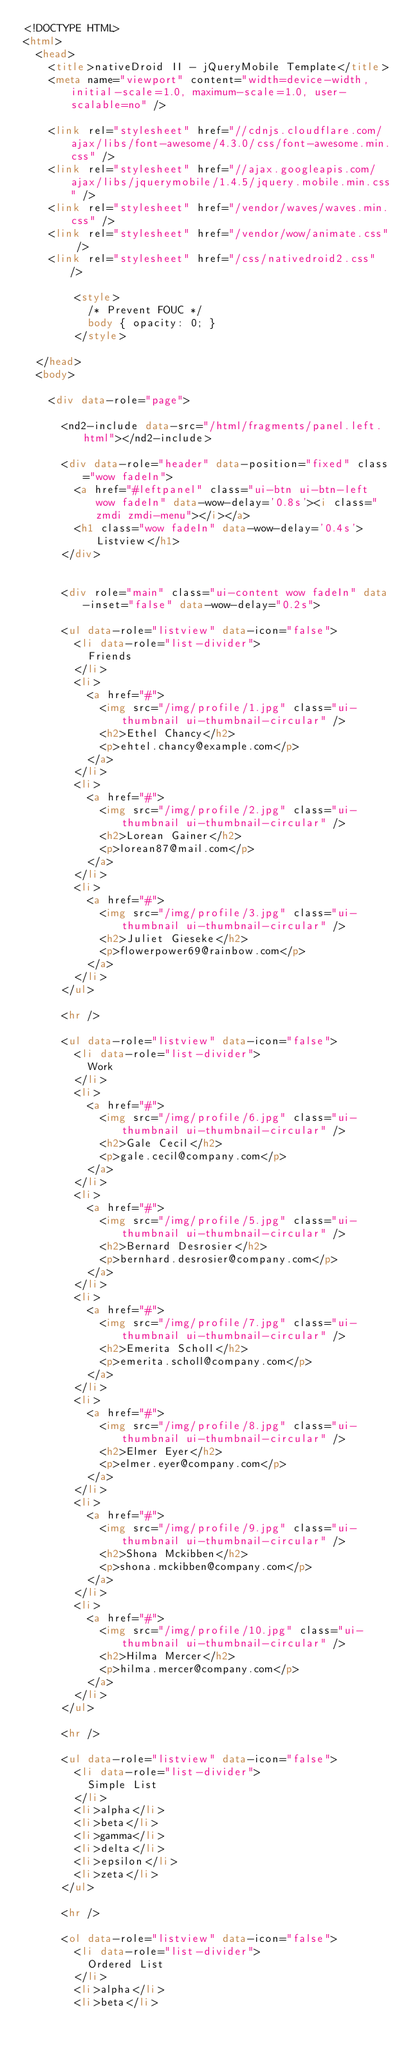<code> <loc_0><loc_0><loc_500><loc_500><_HTML_><!DOCTYPE HTML>
<html>
	<head>
		<title>nativeDroid II - jQueryMobile Template</title>
		<meta name="viewport" content="width=device-width, initial-scale=1.0, maximum-scale=1.0, user-scalable=no" />

		<link rel="stylesheet" href="//cdnjs.cloudflare.com/ajax/libs/font-awesome/4.3.0/css/font-awesome.min.css" />
		<link rel="stylesheet" href="//ajax.googleapis.com/ajax/libs/jquerymobile/1.4.5/jquery.mobile.min.css" />
		<link rel="stylesheet" href="/vendor/waves/waves.min.css" />
		<link rel="stylesheet" href="/vendor/wow/animate.css" />
		<link rel="stylesheet" href="/css/nativedroid2.css" />

				<style>
					/* Prevent FOUC */
					body { opacity: 0; }
				</style>

	</head>
	<body>

		<div data-role="page">

			<nd2-include data-src="/html/fragments/panel.left.html"></nd2-include>

			<div data-role="header" data-position="fixed" class="wow fadeIn">
				<a href="#leftpanel" class="ui-btn ui-btn-left wow fadeIn" data-wow-delay='0.8s'><i class="zmdi zmdi-menu"></i></a>
				<h1 class="wow fadeIn" data-wow-delay='0.4s'>Listview</h1>
			</div>


			<div role="main" class="ui-content wow fadeIn" data-inset="false" data-wow-delay="0.2s">

			<ul data-role="listview" data-icon="false">
				<li data-role="list-divider">
					Friends
				</li>
				<li>
					<a href="#">
						<img src="/img/profile/1.jpg" class="ui-thumbnail ui-thumbnail-circular" />
						<h2>Ethel Chancy</h2>
						<p>ehtel.chancy@example.com</p>
					</a>
				</li>
				<li>
					<a href="#">
						<img src="/img/profile/2.jpg" class="ui-thumbnail ui-thumbnail-circular" />
						<h2>Lorean Gainer</h2>
						<p>lorean87@mail.com</p>
					</a>
				</li>
				<li>
					<a href="#">
						<img src="/img/profile/3.jpg" class="ui-thumbnail ui-thumbnail-circular" />
						<h2>Juliet Gieseke</h2>
						<p>flowerpower69@rainbow.com</p>
					</a>
				</li>
			</ul>

			<hr />

			<ul data-role="listview" data-icon="false">
				<li data-role="list-divider">
					Work
				</li>
				<li>
					<a href="#">
						<img src="/img/profile/6.jpg" class="ui-thumbnail ui-thumbnail-circular" />
						<h2>Gale Cecil</h2>
						<p>gale.cecil@company.com</p>
					</a>
				</li>
				<li>
					<a href="#">
						<img src="/img/profile/5.jpg" class="ui-thumbnail ui-thumbnail-circular" />
						<h2>Bernard Desrosier</h2>
						<p>bernhard.desrosier@company.com</p>
					</a>
				</li>
				<li>
					<a href="#">
						<img src="/img/profile/7.jpg" class="ui-thumbnail ui-thumbnail-circular" />
						<h2>Emerita Scholl</h2>
						<p>emerita.scholl@company.com</p>
					</a>
				</li>
				<li>
					<a href="#">
						<img src="/img/profile/8.jpg" class="ui-thumbnail ui-thumbnail-circular" />
						<h2>Elmer Eyer</h2>
						<p>elmer.eyer@company.com</p>
					</a>
				</li>
				<li>
					<a href="#">
						<img src="/img/profile/9.jpg" class="ui-thumbnail ui-thumbnail-circular" />
						<h2>Shona Mckibben</h2>
						<p>shona.mckibben@company.com</p>
					</a>
				</li>
				<li>
					<a href="#">
						<img src="/img/profile/10.jpg" class="ui-thumbnail ui-thumbnail-circular" />
						<h2>Hilma Mercer</h2>
						<p>hilma.mercer@company.com</p>
					</a>
				</li>
			</ul>

			<hr />

			<ul data-role="listview" data-icon="false">
				<li data-role="list-divider">
					Simple List
				</li>
				<li>alpha</li>
				<li>beta</li>
				<li>gamma</li>
				<li>delta</li>
				<li>epsilon</li>
				<li>zeta</li>
			</ul>

			<hr />

			<ol data-role="listview" data-icon="false">
				<li data-role="list-divider">
					Ordered List
				</li>
				<li>alpha</li>
				<li>beta</li></code> 